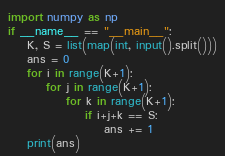Convert code to text. <code><loc_0><loc_0><loc_500><loc_500><_Python_>import numpy as np
if __name__ == "__main__":
    K, S = list(map(int, input().split()))
    ans = 0
    for i in range(K+1):
        for j in range(K+1):
            for k in range(K+1):
                if i+j+k == S:
                    ans += 1
    print(ans)</code> 